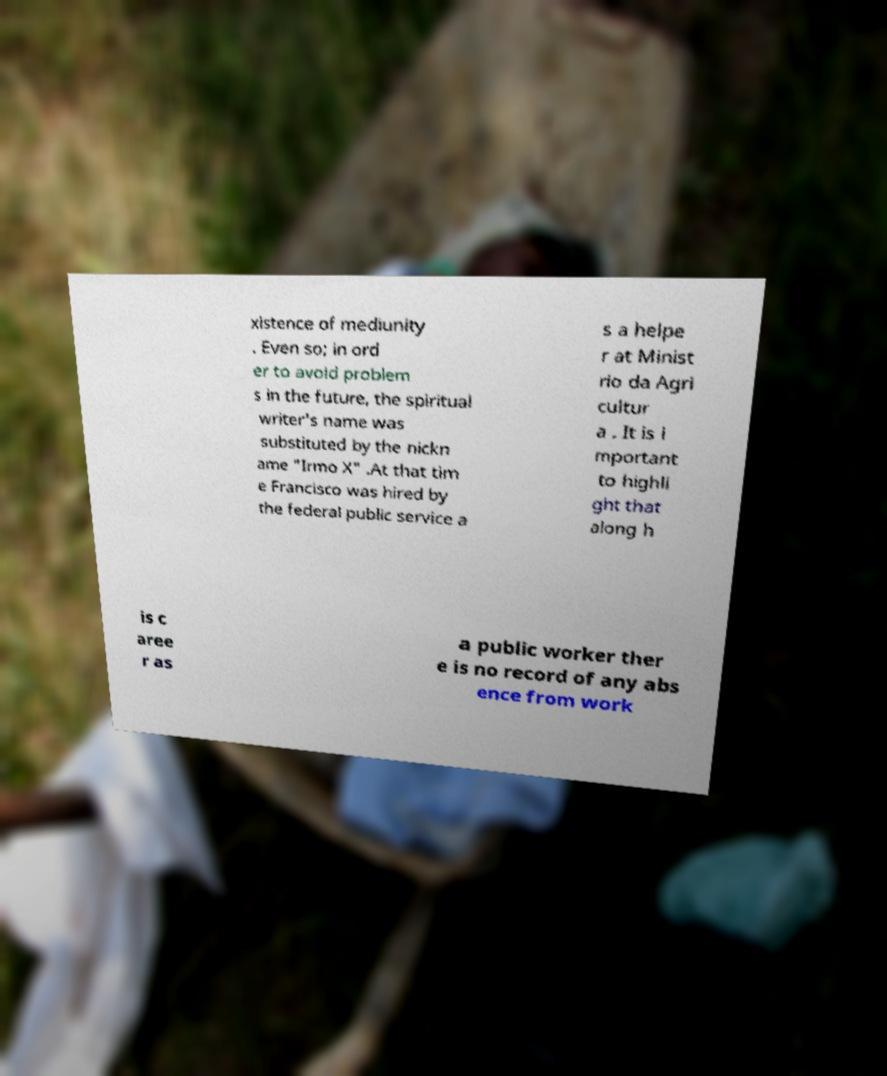For documentation purposes, I need the text within this image transcribed. Could you provide that? xistence of mediunity . Even so; in ord er to avoid problem s in the future, the spiritual writer's name was substituted by the nickn ame "Irmo X" .At that tim e Francisco was hired by the federal public service a s a helpe r at Minist rio da Agri cultur a . It is i mportant to highli ght that along h is c aree r as a public worker ther e is no record of any abs ence from work 